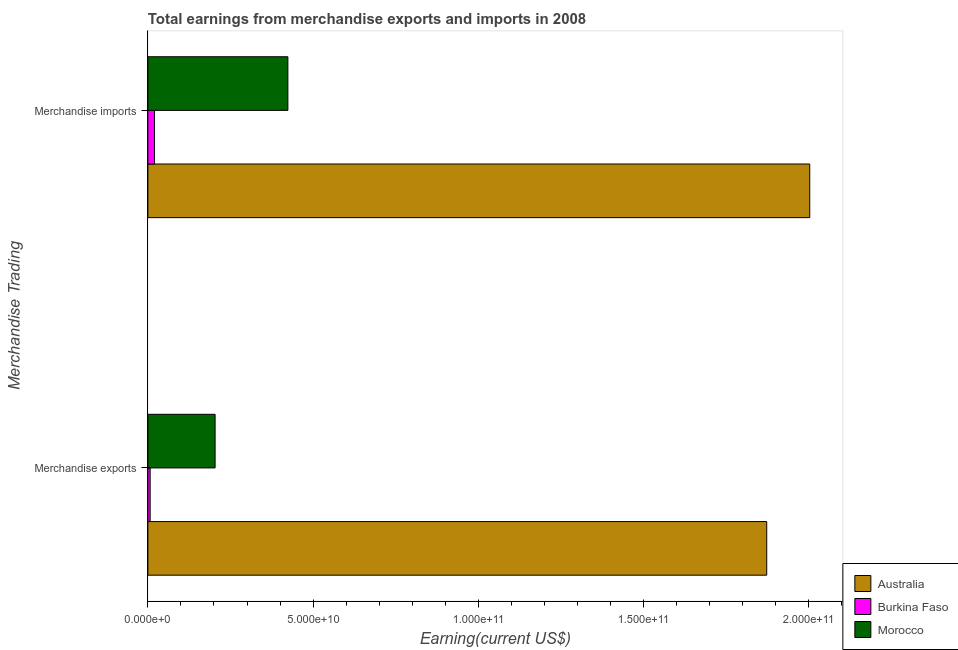How many groups of bars are there?
Provide a succinct answer. 2. Are the number of bars on each tick of the Y-axis equal?
Provide a short and direct response. Yes. What is the label of the 2nd group of bars from the top?
Your answer should be very brief. Merchandise exports. What is the earnings from merchandise exports in Burkina Faso?
Ensure brevity in your answer.  6.93e+08. Across all countries, what is the maximum earnings from merchandise imports?
Provide a short and direct response. 2.00e+11. Across all countries, what is the minimum earnings from merchandise exports?
Keep it short and to the point. 6.93e+08. In which country was the earnings from merchandise imports maximum?
Provide a short and direct response. Australia. In which country was the earnings from merchandise exports minimum?
Your answer should be very brief. Burkina Faso. What is the total earnings from merchandise imports in the graph?
Give a very brief answer. 2.45e+11. What is the difference between the earnings from merchandise exports in Morocco and that in Australia?
Offer a very short reply. -1.67e+11. What is the difference between the earnings from merchandise exports in Burkina Faso and the earnings from merchandise imports in Australia?
Offer a terse response. -2.00e+11. What is the average earnings from merchandise imports per country?
Offer a very short reply. 8.16e+1. What is the difference between the earnings from merchandise exports and earnings from merchandise imports in Morocco?
Your response must be concise. -2.20e+1. In how many countries, is the earnings from merchandise imports greater than 10000000000 US$?
Offer a very short reply. 2. What is the ratio of the earnings from merchandise imports in Morocco to that in Australia?
Offer a terse response. 0.21. In how many countries, is the earnings from merchandise exports greater than the average earnings from merchandise exports taken over all countries?
Provide a short and direct response. 1. What does the 1st bar from the top in Merchandise imports represents?
Offer a very short reply. Morocco. How many bars are there?
Offer a very short reply. 6. Are all the bars in the graph horizontal?
Provide a succinct answer. Yes. How many legend labels are there?
Make the answer very short. 3. What is the title of the graph?
Offer a terse response. Total earnings from merchandise exports and imports in 2008. Does "Togo" appear as one of the legend labels in the graph?
Give a very brief answer. No. What is the label or title of the X-axis?
Provide a short and direct response. Earning(current US$). What is the label or title of the Y-axis?
Provide a succinct answer. Merchandise Trading. What is the Earning(current US$) of Australia in Merchandise exports?
Ensure brevity in your answer.  1.87e+11. What is the Earning(current US$) of Burkina Faso in Merchandise exports?
Offer a very short reply. 6.93e+08. What is the Earning(current US$) of Morocco in Merchandise exports?
Give a very brief answer. 2.03e+1. What is the Earning(current US$) in Australia in Merchandise imports?
Keep it short and to the point. 2.00e+11. What is the Earning(current US$) of Burkina Faso in Merchandise imports?
Provide a succinct answer. 2.02e+09. What is the Earning(current US$) in Morocco in Merchandise imports?
Ensure brevity in your answer.  4.24e+1. Across all Merchandise Trading, what is the maximum Earning(current US$) in Australia?
Provide a succinct answer. 2.00e+11. Across all Merchandise Trading, what is the maximum Earning(current US$) in Burkina Faso?
Keep it short and to the point. 2.02e+09. Across all Merchandise Trading, what is the maximum Earning(current US$) in Morocco?
Offer a very short reply. 4.24e+1. Across all Merchandise Trading, what is the minimum Earning(current US$) in Australia?
Give a very brief answer. 1.87e+11. Across all Merchandise Trading, what is the minimum Earning(current US$) of Burkina Faso?
Give a very brief answer. 6.93e+08. Across all Merchandise Trading, what is the minimum Earning(current US$) in Morocco?
Your answer should be very brief. 2.03e+1. What is the total Earning(current US$) in Australia in the graph?
Keep it short and to the point. 3.88e+11. What is the total Earning(current US$) of Burkina Faso in the graph?
Offer a terse response. 2.71e+09. What is the total Earning(current US$) in Morocco in the graph?
Offer a very short reply. 6.27e+1. What is the difference between the Earning(current US$) of Australia in Merchandise exports and that in Merchandise imports?
Offer a terse response. -1.30e+1. What is the difference between the Earning(current US$) in Burkina Faso in Merchandise exports and that in Merchandise imports?
Your answer should be very brief. -1.32e+09. What is the difference between the Earning(current US$) in Morocco in Merchandise exports and that in Merchandise imports?
Ensure brevity in your answer.  -2.20e+1. What is the difference between the Earning(current US$) of Australia in Merchandise exports and the Earning(current US$) of Burkina Faso in Merchandise imports?
Ensure brevity in your answer.  1.85e+11. What is the difference between the Earning(current US$) of Australia in Merchandise exports and the Earning(current US$) of Morocco in Merchandise imports?
Give a very brief answer. 1.45e+11. What is the difference between the Earning(current US$) of Burkina Faso in Merchandise exports and the Earning(current US$) of Morocco in Merchandise imports?
Offer a very short reply. -4.17e+1. What is the average Earning(current US$) of Australia per Merchandise Trading?
Offer a very short reply. 1.94e+11. What is the average Earning(current US$) in Burkina Faso per Merchandise Trading?
Offer a very short reply. 1.36e+09. What is the average Earning(current US$) of Morocco per Merchandise Trading?
Your response must be concise. 3.14e+1. What is the difference between the Earning(current US$) in Australia and Earning(current US$) in Burkina Faso in Merchandise exports?
Your answer should be very brief. 1.87e+11. What is the difference between the Earning(current US$) in Australia and Earning(current US$) in Morocco in Merchandise exports?
Offer a very short reply. 1.67e+11. What is the difference between the Earning(current US$) of Burkina Faso and Earning(current US$) of Morocco in Merchandise exports?
Offer a very short reply. -1.97e+1. What is the difference between the Earning(current US$) in Australia and Earning(current US$) in Burkina Faso in Merchandise imports?
Offer a terse response. 1.98e+11. What is the difference between the Earning(current US$) of Australia and Earning(current US$) of Morocco in Merchandise imports?
Offer a terse response. 1.58e+11. What is the difference between the Earning(current US$) in Burkina Faso and Earning(current US$) in Morocco in Merchandise imports?
Provide a succinct answer. -4.03e+1. What is the ratio of the Earning(current US$) in Australia in Merchandise exports to that in Merchandise imports?
Your answer should be very brief. 0.94. What is the ratio of the Earning(current US$) in Burkina Faso in Merchandise exports to that in Merchandise imports?
Your response must be concise. 0.34. What is the ratio of the Earning(current US$) in Morocco in Merchandise exports to that in Merchandise imports?
Give a very brief answer. 0.48. What is the difference between the highest and the second highest Earning(current US$) in Australia?
Your answer should be very brief. 1.30e+1. What is the difference between the highest and the second highest Earning(current US$) of Burkina Faso?
Offer a terse response. 1.32e+09. What is the difference between the highest and the second highest Earning(current US$) of Morocco?
Ensure brevity in your answer.  2.20e+1. What is the difference between the highest and the lowest Earning(current US$) in Australia?
Make the answer very short. 1.30e+1. What is the difference between the highest and the lowest Earning(current US$) in Burkina Faso?
Keep it short and to the point. 1.32e+09. What is the difference between the highest and the lowest Earning(current US$) of Morocco?
Offer a very short reply. 2.20e+1. 